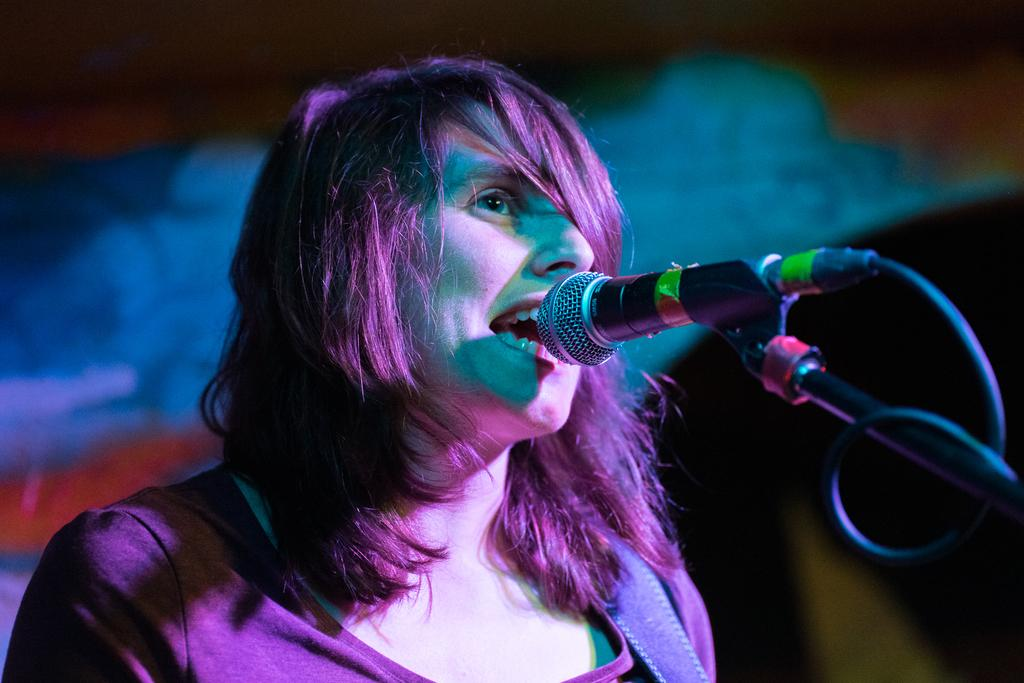What is the main subject of the image? The main subject of the image is a woman. What is the woman doing in the image? The woman appears to be singing in the image. What object is the woman standing in front of? The woman is in front of a microphone on a stand. Can you describe the background of the image? The background of the image is blurry. What type of scarf is the woman wearing in the image? There is no scarf visible in the image. How many cats can be seen playing with the microphone in the image? There are no cats present in the image; it features a woman singing in front of a microphone. 